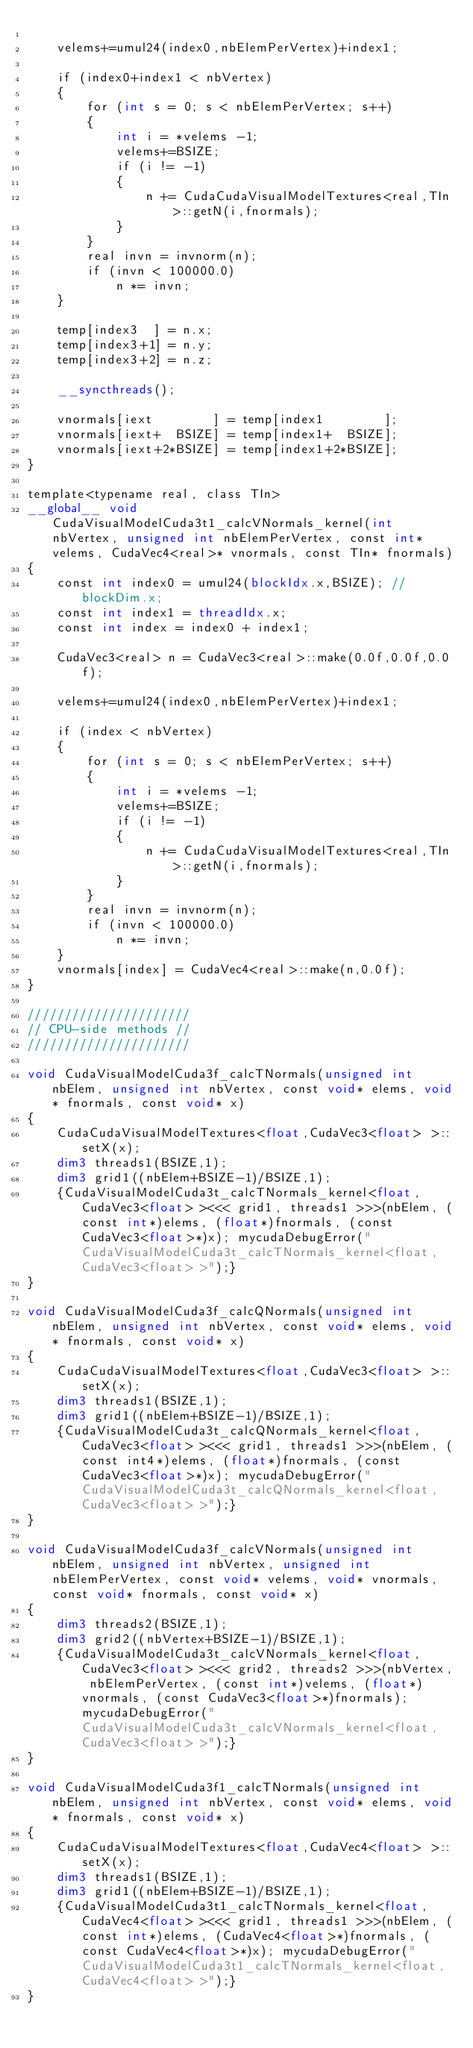Convert code to text. <code><loc_0><loc_0><loc_500><loc_500><_Cuda_>
    velems+=umul24(index0,nbElemPerVertex)+index1;

    if (index0+index1 < nbVertex)
    {
        for (int s = 0; s < nbElemPerVertex; s++)
        {
            int i = *velems -1;
            velems+=BSIZE;
            if (i != -1)
            {
                n += CudaCudaVisualModelTextures<real,TIn>::getN(i,fnormals);
            }
        }
        real invn = invnorm(n);
        if (invn < 100000.0)
            n *= invn;
    }

    temp[index3  ] = n.x;
    temp[index3+1] = n.y;
    temp[index3+2] = n.z;

    __syncthreads();

    vnormals[iext        ] = temp[index1        ];
    vnormals[iext+  BSIZE] = temp[index1+  BSIZE];
    vnormals[iext+2*BSIZE] = temp[index1+2*BSIZE];
}

template<typename real, class TIn>
__global__ void CudaVisualModelCuda3t1_calcVNormals_kernel(int nbVertex, unsigned int nbElemPerVertex, const int* velems, CudaVec4<real>* vnormals, const TIn* fnormals)
{
    const int index0 = umul24(blockIdx.x,BSIZE); //blockDim.x;
    const int index1 = threadIdx.x;
    const int index = index0 + index1;

    CudaVec3<real> n = CudaVec3<real>::make(0.0f,0.0f,0.0f);

    velems+=umul24(index0,nbElemPerVertex)+index1;

    if (index < nbVertex)
    {
        for (int s = 0; s < nbElemPerVertex; s++)
        {
            int i = *velems -1;
            velems+=BSIZE;
            if (i != -1)
            {
                n += CudaCudaVisualModelTextures<real,TIn>::getN(i,fnormals);
            }
        }
        real invn = invnorm(n);
        if (invn < 100000.0)
            n *= invn;
    }
    vnormals[index] = CudaVec4<real>::make(n,0.0f);
}

//////////////////////
// CPU-side methods //
//////////////////////

void CudaVisualModelCuda3f_calcTNormals(unsigned int nbElem, unsigned int nbVertex, const void* elems, void* fnormals, const void* x)
{
    CudaCudaVisualModelTextures<float,CudaVec3<float> >::setX(x);
    dim3 threads1(BSIZE,1);
    dim3 grid1((nbElem+BSIZE-1)/BSIZE,1);
    {CudaVisualModelCuda3t_calcTNormals_kernel<float, CudaVec3<float> ><<< grid1, threads1 >>>(nbElem, (const int*)elems, (float*)fnormals, (const CudaVec3<float>*)x); mycudaDebugError("CudaVisualModelCuda3t_calcTNormals_kernel<float, CudaVec3<float> >");}
}

void CudaVisualModelCuda3f_calcQNormals(unsigned int nbElem, unsigned int nbVertex, const void* elems, void* fnormals, const void* x)
{
    CudaCudaVisualModelTextures<float,CudaVec3<float> >::setX(x);
    dim3 threads1(BSIZE,1);
    dim3 grid1((nbElem+BSIZE-1)/BSIZE,1);
    {CudaVisualModelCuda3t_calcQNormals_kernel<float, CudaVec3<float> ><<< grid1, threads1 >>>(nbElem, (const int4*)elems, (float*)fnormals, (const CudaVec3<float>*)x); mycudaDebugError("CudaVisualModelCuda3t_calcQNormals_kernel<float, CudaVec3<float> >");}
}

void CudaVisualModelCuda3f_calcVNormals(unsigned int nbElem, unsigned int nbVertex, unsigned int nbElemPerVertex, const void* velems, void* vnormals, const void* fnormals, const void* x)
{
    dim3 threads2(BSIZE,1);
    dim3 grid2((nbVertex+BSIZE-1)/BSIZE,1);
    {CudaVisualModelCuda3t_calcVNormals_kernel<float, CudaVec3<float> ><<< grid2, threads2 >>>(nbVertex, nbElemPerVertex, (const int*)velems, (float*)vnormals, (const CudaVec3<float>*)fnormals); mycudaDebugError("CudaVisualModelCuda3t_calcVNormals_kernel<float, CudaVec3<float> >");}
}

void CudaVisualModelCuda3f1_calcTNormals(unsigned int nbElem, unsigned int nbVertex, const void* elems, void* fnormals, const void* x)
{
    CudaCudaVisualModelTextures<float,CudaVec4<float> >::setX(x);
    dim3 threads1(BSIZE,1);
    dim3 grid1((nbElem+BSIZE-1)/BSIZE,1);
    {CudaVisualModelCuda3t1_calcTNormals_kernel<float, CudaVec4<float> ><<< grid1, threads1 >>>(nbElem, (const int*)elems, (CudaVec4<float>*)fnormals, (const CudaVec4<float>*)x); mycudaDebugError("CudaVisualModelCuda3t1_calcTNormals_kernel<float, CudaVec4<float> >");}
}
</code> 